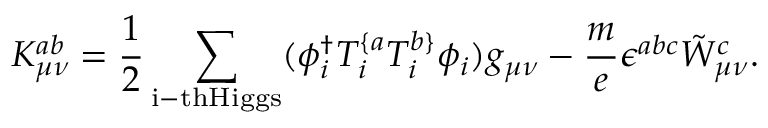Convert formula to latex. <formula><loc_0><loc_0><loc_500><loc_500>K _ { \mu \nu } ^ { a b } = \frac { 1 } { 2 } \sum _ { i - t h H i g g s } ( \phi _ { i } ^ { \dag } T _ { i } ^ { \{ a } T _ { i } ^ { b \} } \phi _ { i } ) g _ { \mu \nu } - \frac { m } { e } \epsilon ^ { a b c } \tilde { W } _ { \mu \nu } ^ { c } .</formula> 